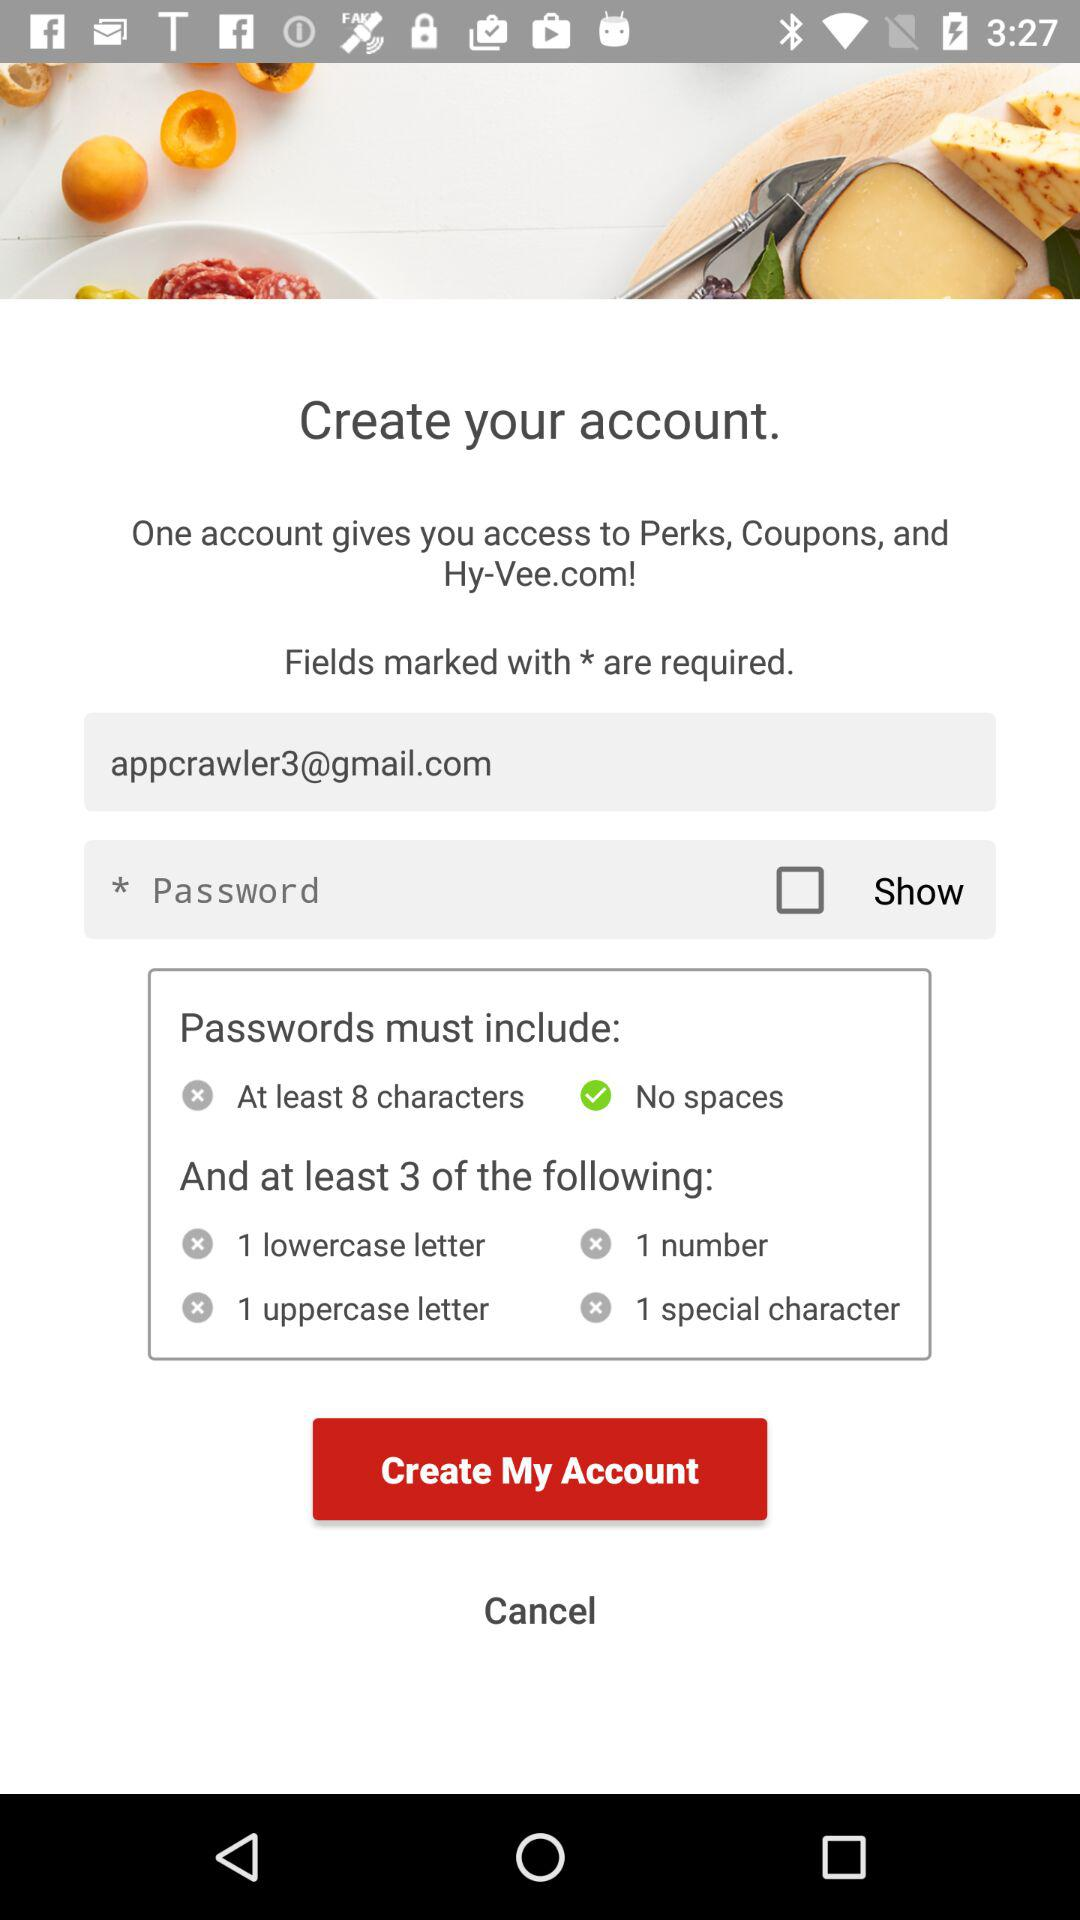What is the status of the "Show" password? The status of the "Show" password is "off". 